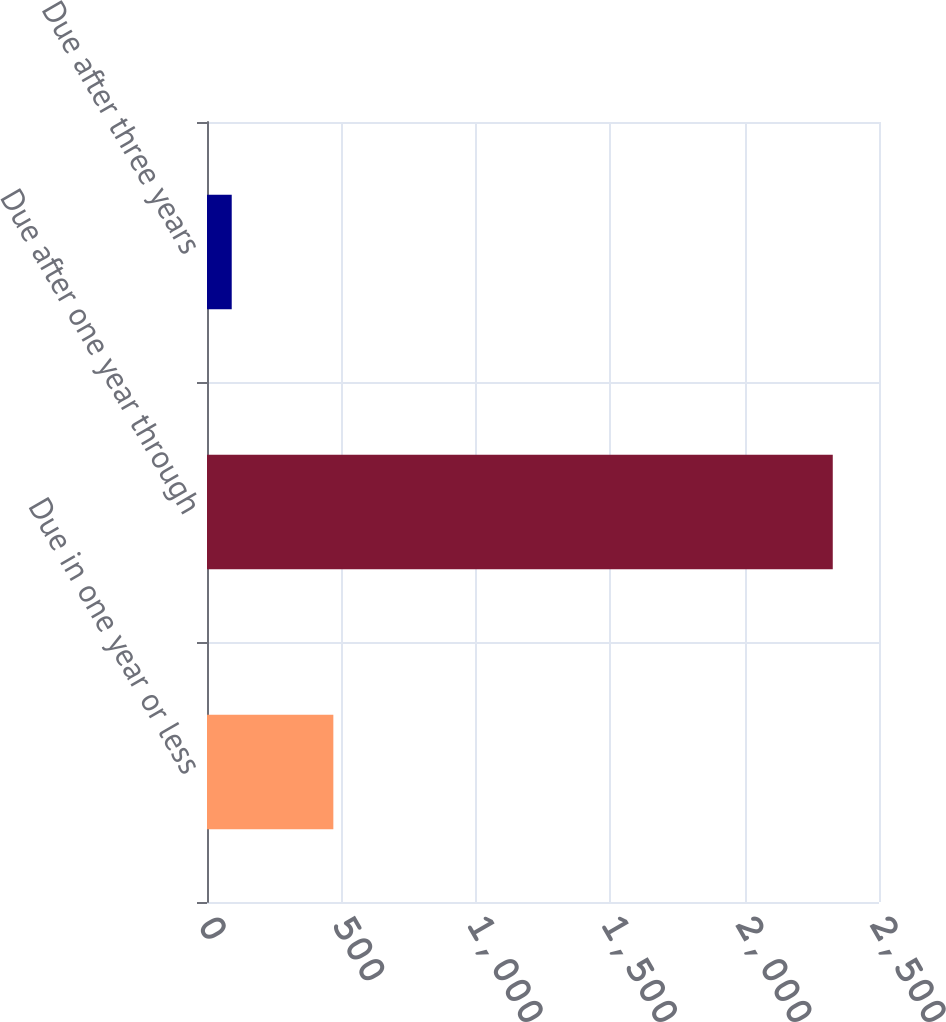<chart> <loc_0><loc_0><loc_500><loc_500><bar_chart><fcel>Due in one year or less<fcel>Due after one year through<fcel>Due after three years<nl><fcel>470<fcel>2328<fcel>92<nl></chart> 